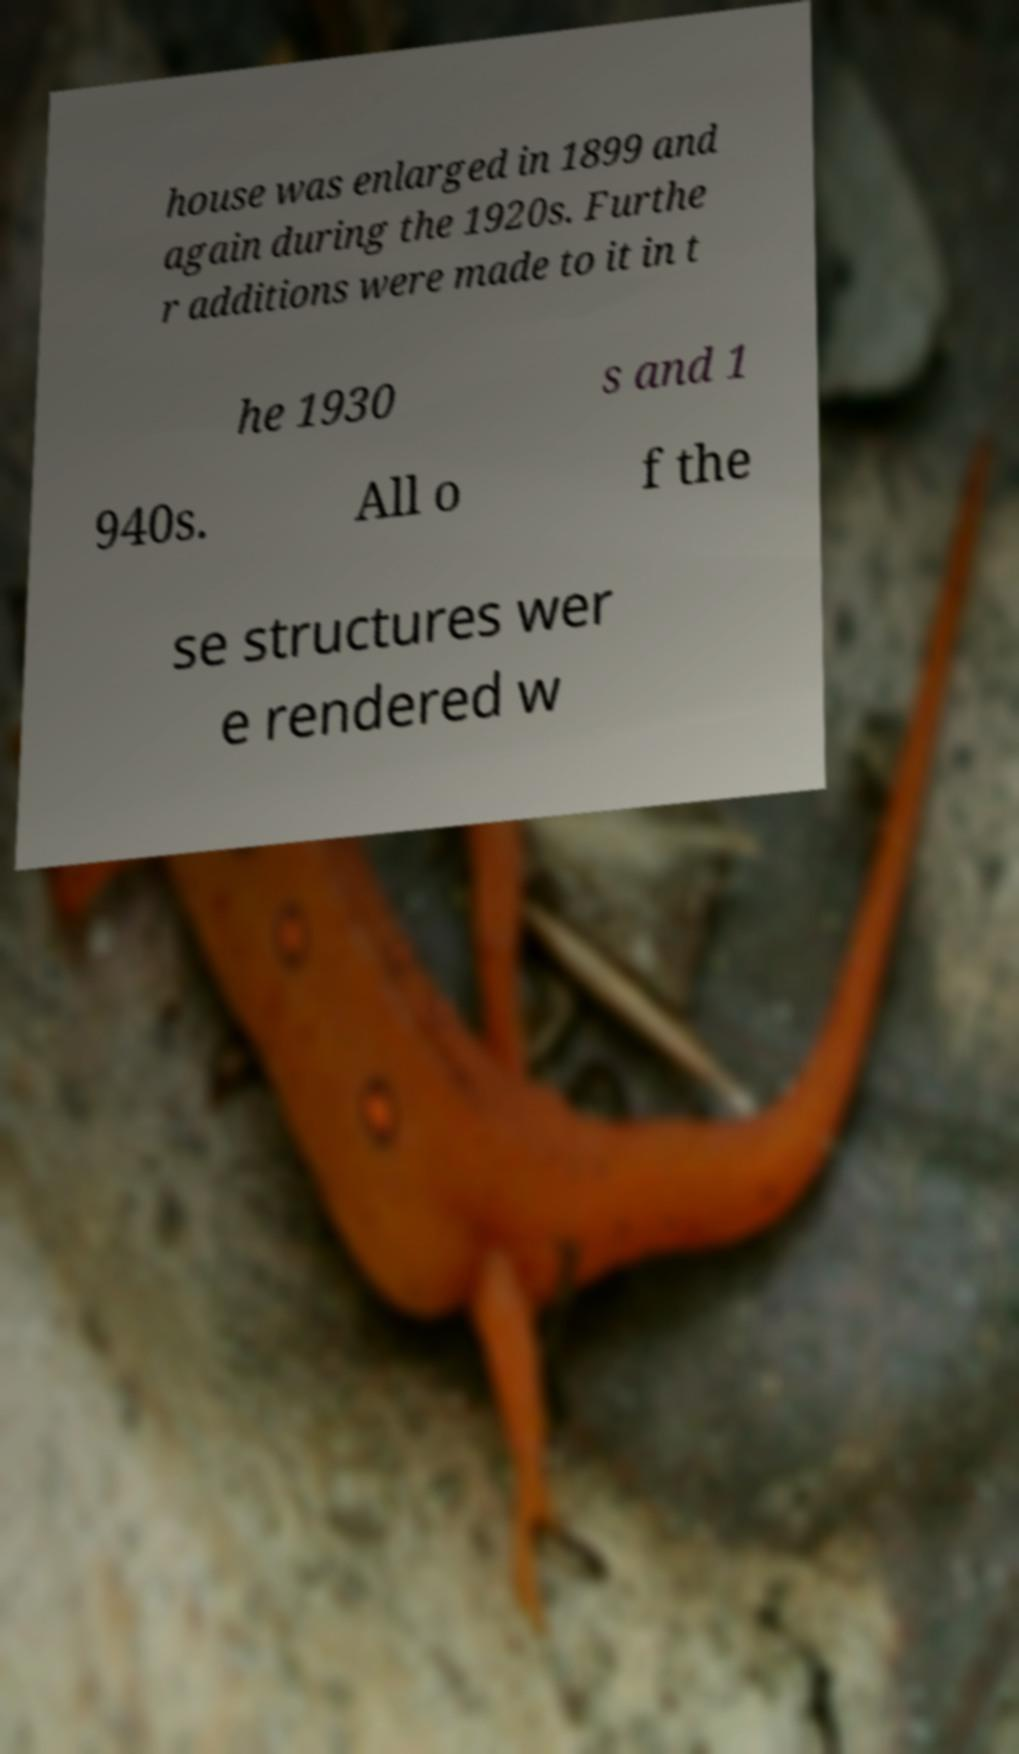Please identify and transcribe the text found in this image. house was enlarged in 1899 and again during the 1920s. Furthe r additions were made to it in t he 1930 s and 1 940s. All o f the se structures wer e rendered w 